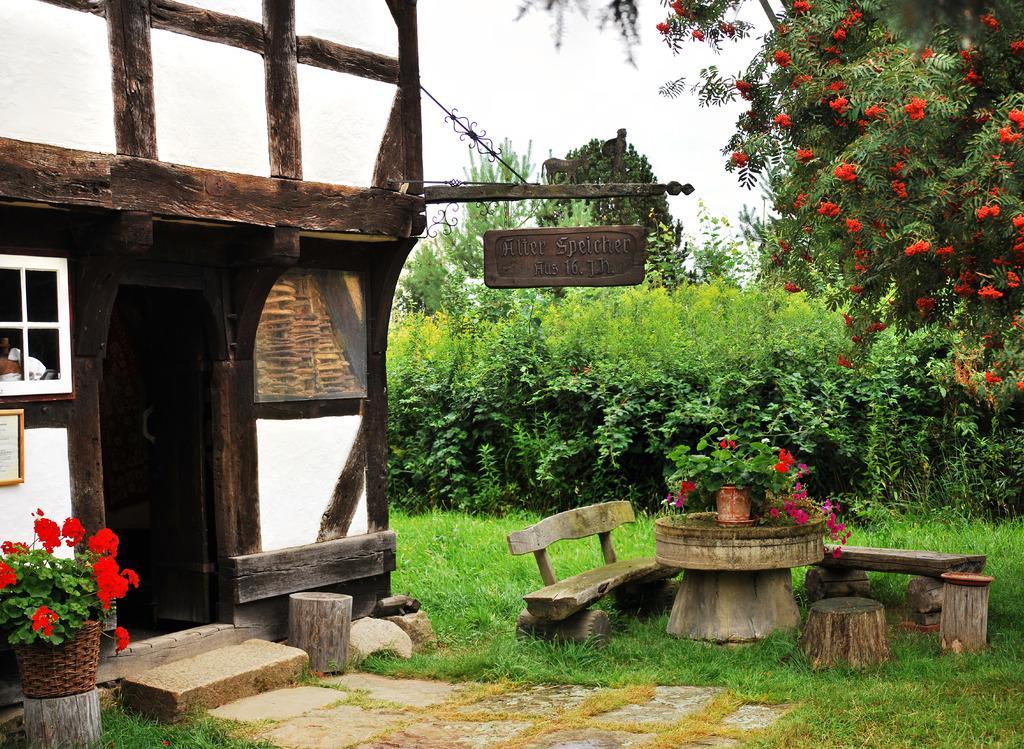Describe this image in one or two sentences. In this picture there is a wooden hut at the left side of the image and there are two wooden benches at the right side of the image and a small table, there is a small flower pot at the left side of the image and a name plate which is hanged from the log at the center of the image. 